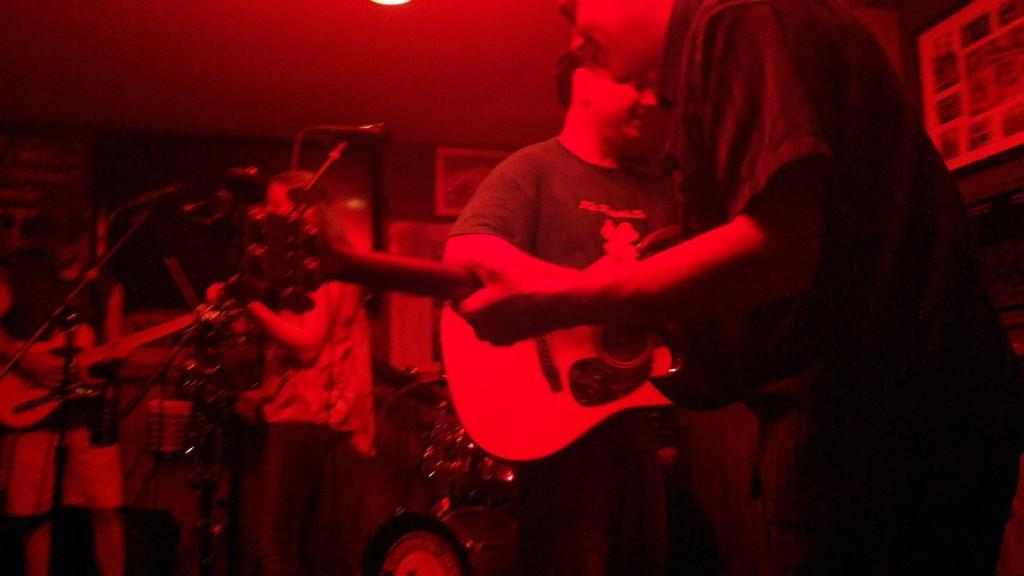What are the men in the image doing? The men in the image are playing guitar. What objects are in front of the men? There are microphones in front of the men. How many bananas can be seen on the guitar in the image? There are no bananas present in the image, and the guitar is not mentioned as having any bananas on it. 